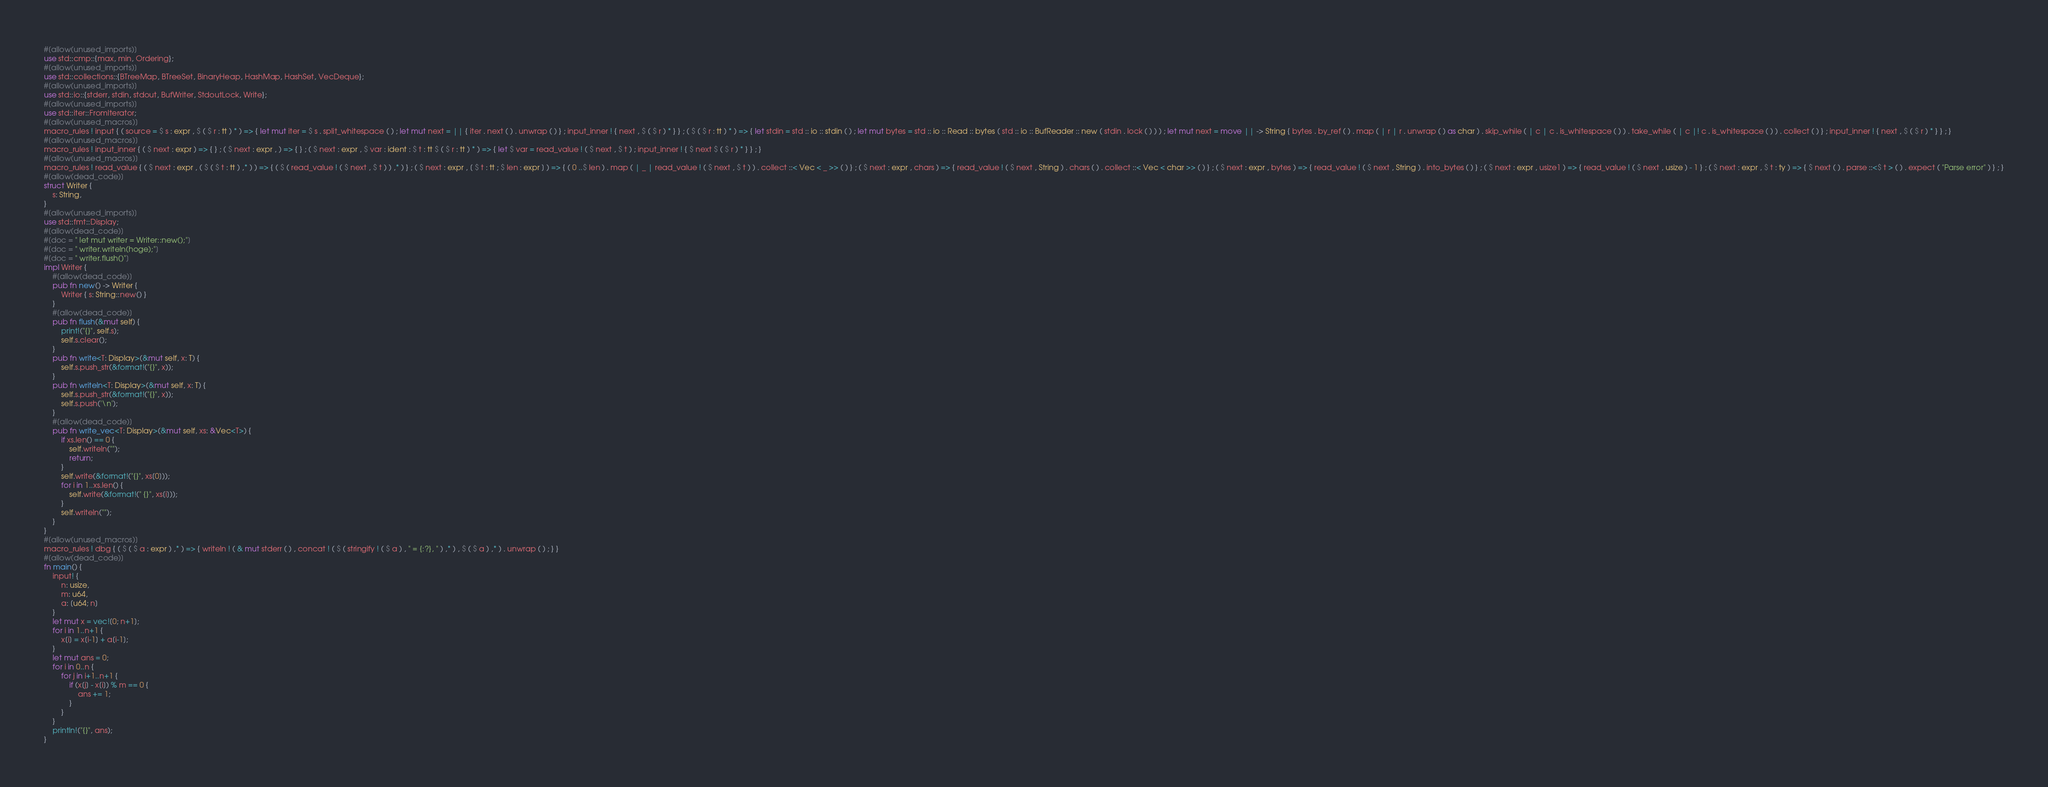<code> <loc_0><loc_0><loc_500><loc_500><_Rust_>#[allow(unused_imports)]
use std::cmp::{max, min, Ordering};
#[allow(unused_imports)]
use std::collections::{BTreeMap, BTreeSet, BinaryHeap, HashMap, HashSet, VecDeque};
#[allow(unused_imports)]
use std::io::{stderr, stdin, stdout, BufWriter, StdoutLock, Write};
#[allow(unused_imports)]
use std::iter::FromIterator;
#[allow(unused_macros)]
macro_rules ! input { ( source = $ s : expr , $ ( $ r : tt ) * ) => { let mut iter = $ s . split_whitespace ( ) ; let mut next = || { iter . next ( ) . unwrap ( ) } ; input_inner ! { next , $ ( $ r ) * } } ; ( $ ( $ r : tt ) * ) => { let stdin = std :: io :: stdin ( ) ; let mut bytes = std :: io :: Read :: bytes ( std :: io :: BufReader :: new ( stdin . lock ( ) ) ) ; let mut next = move || -> String { bytes . by_ref ( ) . map ( | r | r . unwrap ( ) as char ) . skip_while ( | c | c . is_whitespace ( ) ) . take_while ( | c |! c . is_whitespace ( ) ) . collect ( ) } ; input_inner ! { next , $ ( $ r ) * } } ; }
#[allow(unused_macros)]
macro_rules ! input_inner { ( $ next : expr ) => { } ; ( $ next : expr , ) => { } ; ( $ next : expr , $ var : ident : $ t : tt $ ( $ r : tt ) * ) => { let $ var = read_value ! ( $ next , $ t ) ; input_inner ! { $ next $ ( $ r ) * } } ; }
#[allow(unused_macros)]
macro_rules ! read_value { ( $ next : expr , ( $ ( $ t : tt ) ,* ) ) => { ( $ ( read_value ! ( $ next , $ t ) ) ,* ) } ; ( $ next : expr , [ $ t : tt ; $ len : expr ] ) => { ( 0 ..$ len ) . map ( | _ | read_value ! ( $ next , $ t ) ) . collect ::< Vec < _ >> ( ) } ; ( $ next : expr , chars ) => { read_value ! ( $ next , String ) . chars ( ) . collect ::< Vec < char >> ( ) } ; ( $ next : expr , bytes ) => { read_value ! ( $ next , String ) . into_bytes ( ) } ; ( $ next : expr , usize1 ) => { read_value ! ( $ next , usize ) - 1 } ; ( $ next : expr , $ t : ty ) => { $ next ( ) . parse ::<$ t > ( ) . expect ( "Parse error" ) } ; }
#[allow(dead_code)]
struct Writer {
    s: String,
}
#[allow(unused_imports)]
use std::fmt::Display;
#[allow(dead_code)]
#[doc = " let mut writer = Writer::new();"]
#[doc = " writer.writeln(hoge);"]
#[doc = " writer.flush()"]
impl Writer {
    #[allow(dead_code)]
    pub fn new() -> Writer {
        Writer { s: String::new() }
    }
    #[allow(dead_code)]
    pub fn flush(&mut self) {
        print!("{}", self.s);
        self.s.clear();
    }
    pub fn write<T: Display>(&mut self, x: T) {
        self.s.push_str(&format!("{}", x));
    }
    pub fn writeln<T: Display>(&mut self, x: T) {
        self.s.push_str(&format!("{}", x));
        self.s.push('\n');
    }
    #[allow(dead_code)]
    pub fn write_vec<T: Display>(&mut self, xs: &Vec<T>) {
        if xs.len() == 0 {
            self.writeln("");
            return;
        }
        self.write(&format!("{}", xs[0]));
        for i in 1..xs.len() {
            self.write(&format!(" {}", xs[i]));
        }
        self.writeln("");
    }
}
#[allow(unused_macros)]
macro_rules ! dbg { ( $ ( $ a : expr ) ,* ) => { writeln ! ( & mut stderr ( ) , concat ! ( $ ( stringify ! ( $ a ) , " = {:?}, " ) ,* ) , $ ( $ a ) ,* ) . unwrap ( ) ; } }
#[allow(dead_code)]
fn main() {
    input! {
        n: usize,
        m: u64,
        a: [u64; n]
    }
    let mut x = vec![0; n+1];
    for i in 1..n+1 {
        x[i] = x[i-1] + a[i-1];
    }
    let mut ans = 0;
    for i in 0..n {
        for j in i+1..n+1 {
            if (x[j] - x[i]) % m == 0 {
                ans += 1;
            }
        }
    }
    println!("{}", ans);
}</code> 